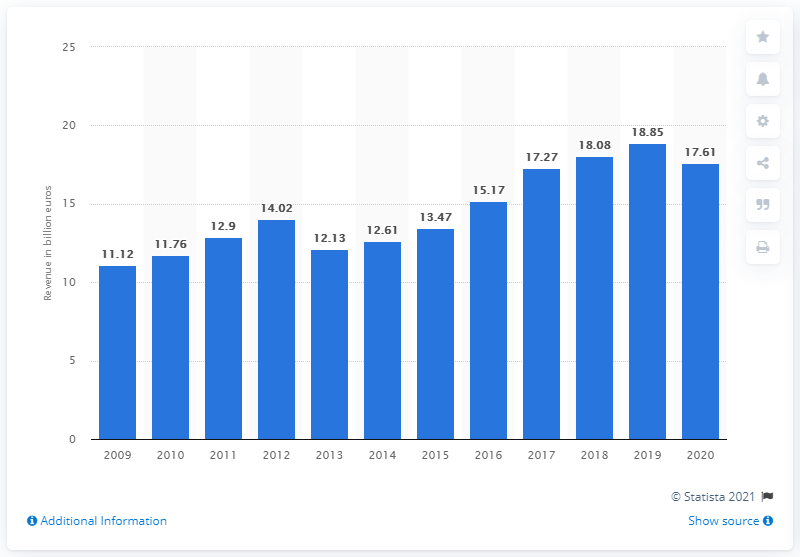List a handful of essential elements in this visual. In 2020, HeidelbergCement generated €17.61 billion in revenue. 